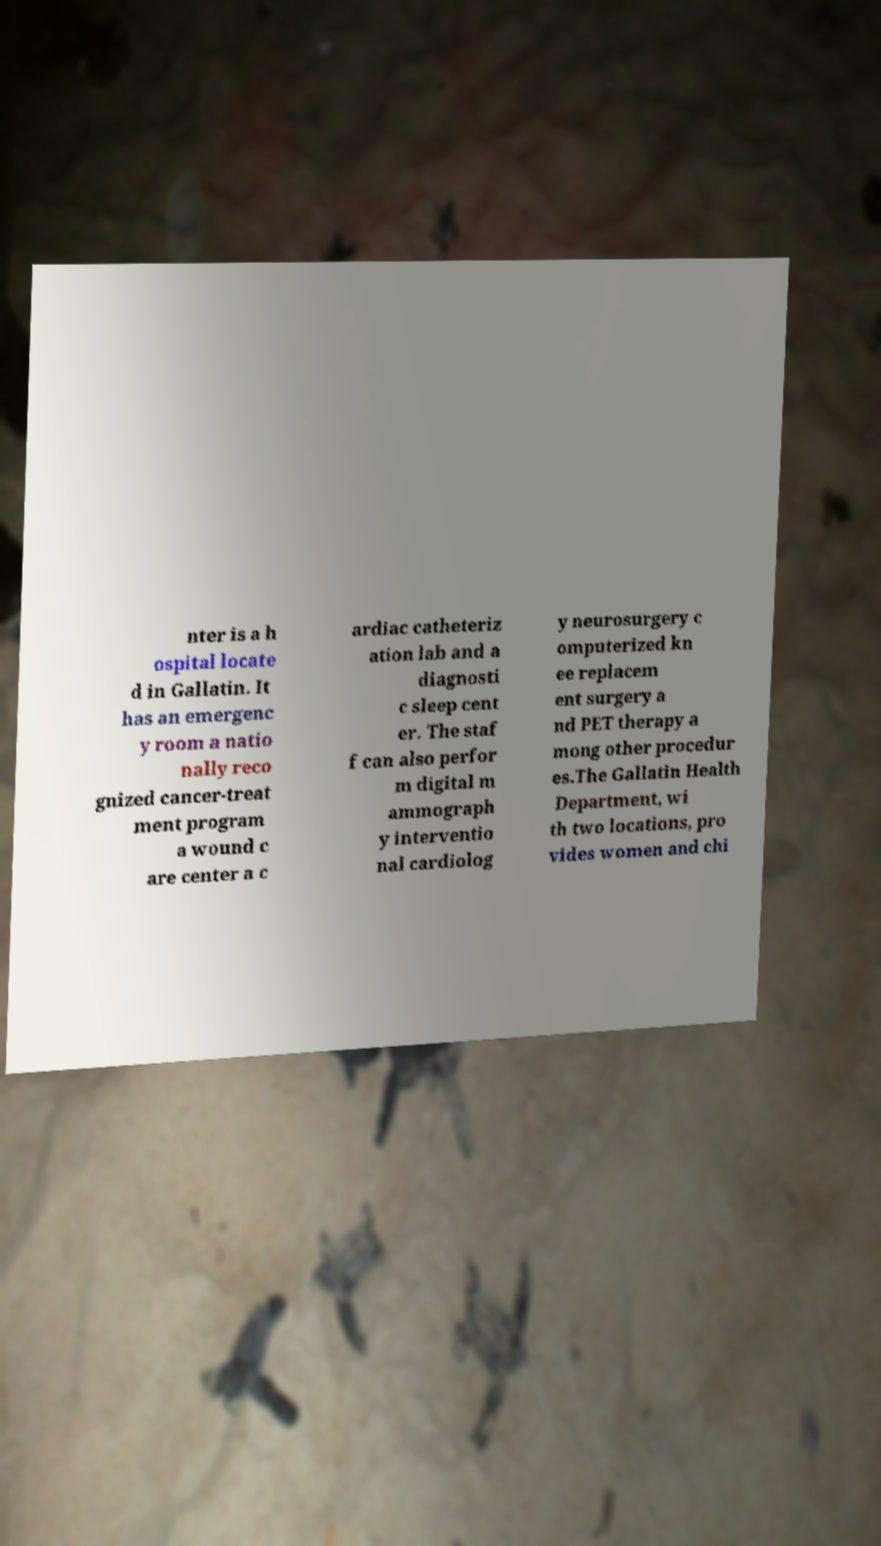Could you assist in decoding the text presented in this image and type it out clearly? nter is a h ospital locate d in Gallatin. It has an emergenc y room a natio nally reco gnized cancer-treat ment program a wound c are center a c ardiac catheteriz ation lab and a diagnosti c sleep cent er. The staf f can also perfor m digital m ammograph y interventio nal cardiolog y neurosurgery c omputerized kn ee replacem ent surgery a nd PET therapy a mong other procedur es.The Gallatin Health Department, wi th two locations, pro vides women and chi 